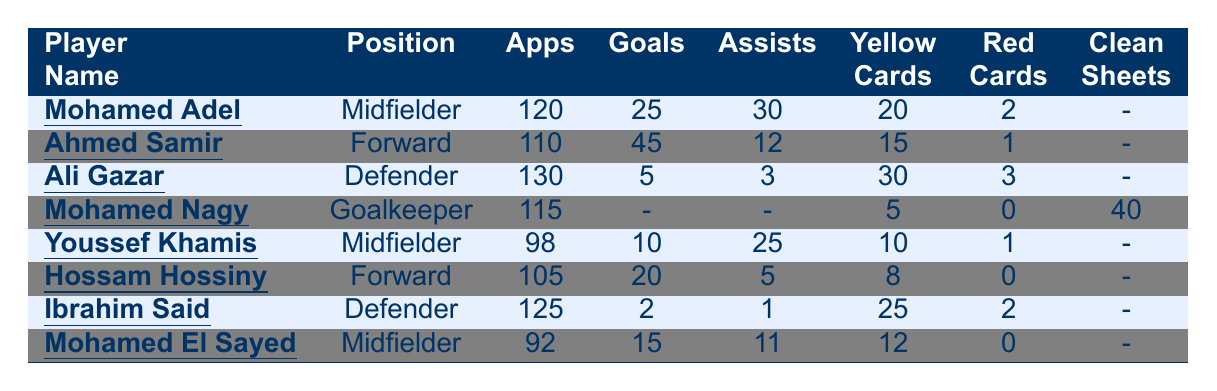How many goals did Mohamed Adel score? The table shows that Mohamed Adel scored 25 goals.
Answer: 25 What position does Ahmed Samir play? The table indicates that Ahmed Samir is a Forward.
Answer: Forward Which player has the highest number of yellow cards? By examining the yellow cards, Ali Gazar has the highest count at 30.
Answer: 30 What is the total number of appearances for all players? Summing the appearances gives: 120 + 110 + 130 + 115 + 98 + 105 + 125 + 92 = 1,005.
Answer: 1005 How many goals did Hossam Hossiny score compared to Youssef Khamis? Hossam Hossiny scored 20 goals, while Youssef Khamis scored 10 goals; thus, Hossam scored 10 more goals than Youssef.
Answer: 10 more True or False: Mohamed Nagy has a clean sheet record of 40. The table confirms that Mohamed Nagy has 40 clean sheets, so the statement is true.
Answer: True What is the average number of goals scored by midfielders? The midfielders are Mohamed Adel (25), Youssef Khamis (10), and Mohamed El Sayed (15). The average is (25 + 10 + 15) / 3 = 50 / 3 ≈ 16.67.
Answer: 16.67 Which player has the fewest number of goals, and how many did they score? In the table, Ibrahim Said shows only 2 goals, making him the player with the fewest goals.
Answer: Ibrahim Said, 2 goals How many players received a red card? The players with red cards are Mohamed Adel (2), Ahmed Samir (1), Ali Gazar (3), Ibrahim Said (2), and Youssef Khamis (1), totaling 9 red cards.
Answer: 9 red cards What is the total number of assists from all players? The assists add up as follows: 30 + 12 + 3 + 0 + 25 + 5 + 1 + 11 = 87 assists in total.
Answer: 87 